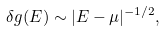Convert formula to latex. <formula><loc_0><loc_0><loc_500><loc_500>\delta g ( E ) \sim | E - \mu | ^ { - 1 / 2 } ,</formula> 